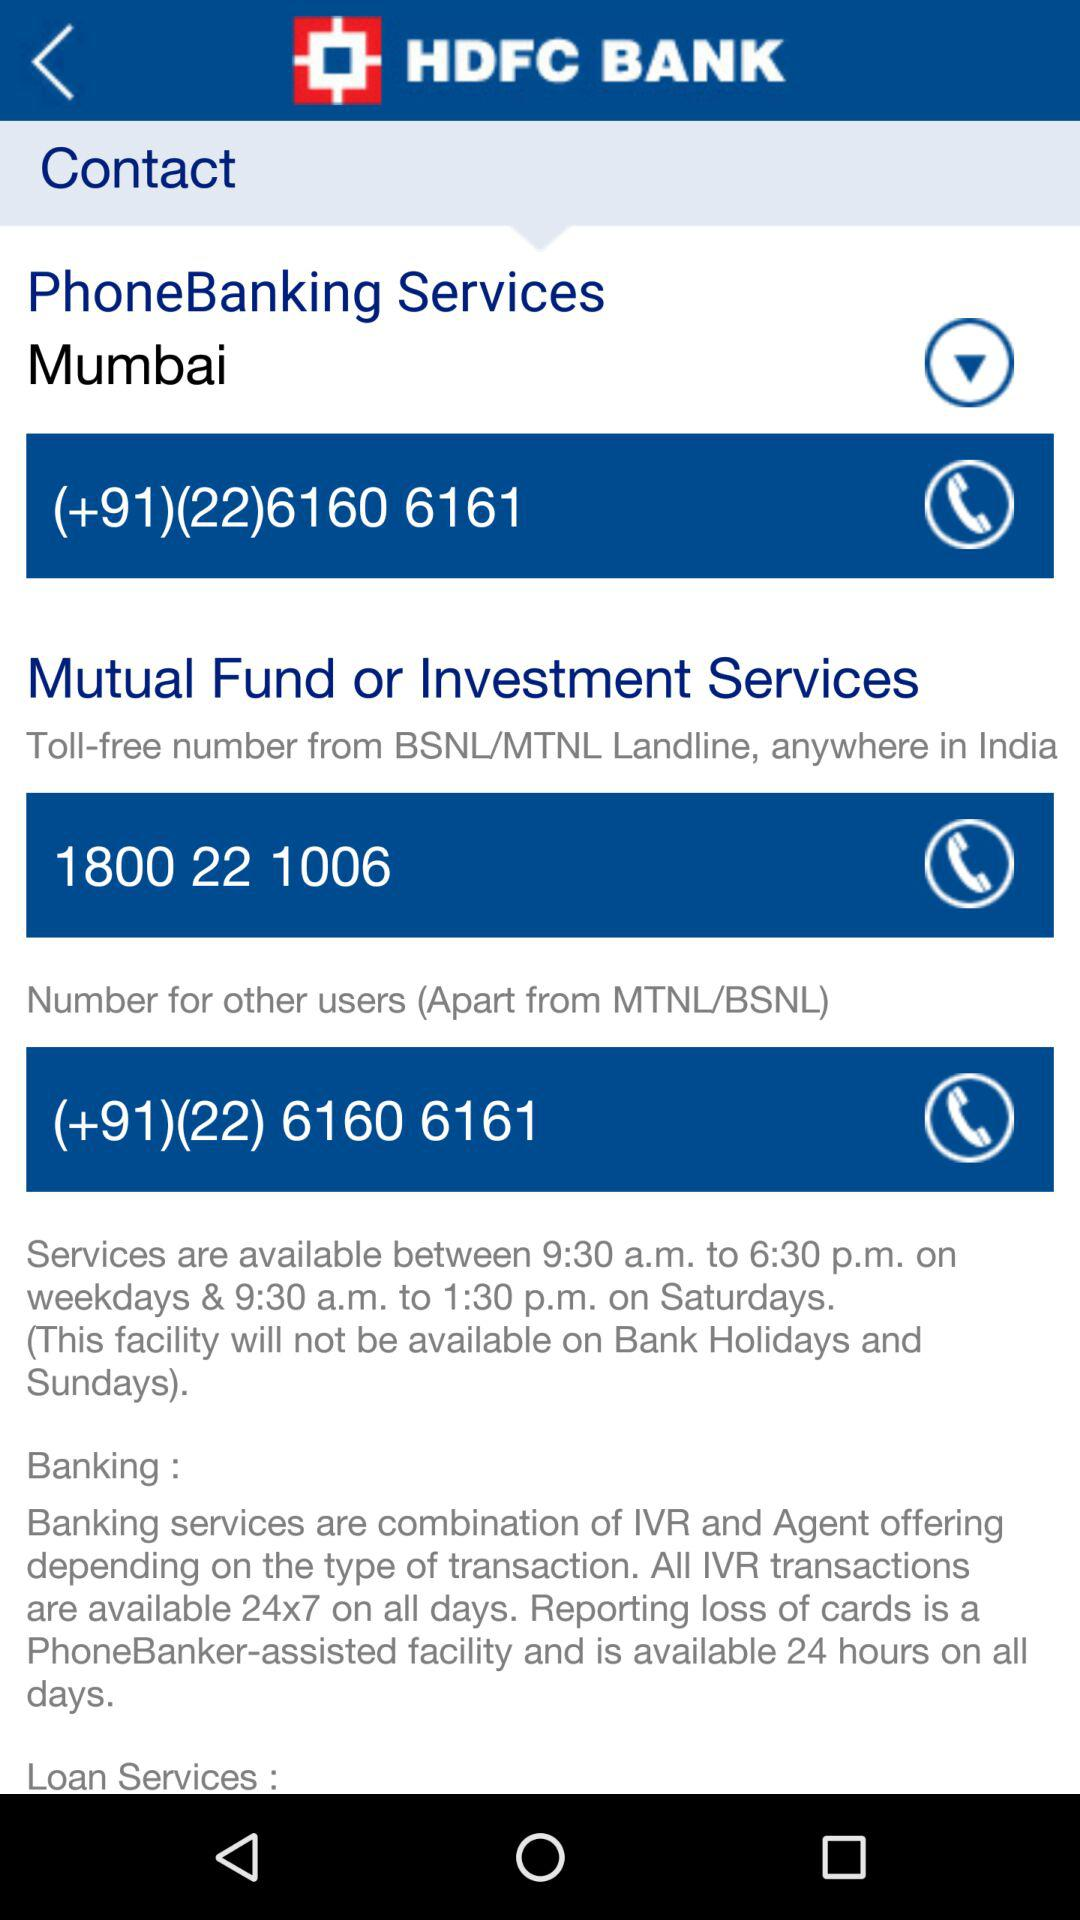What is the communication number for the other users? The communication number for the other users is (+91) (22) 6160 6161. 